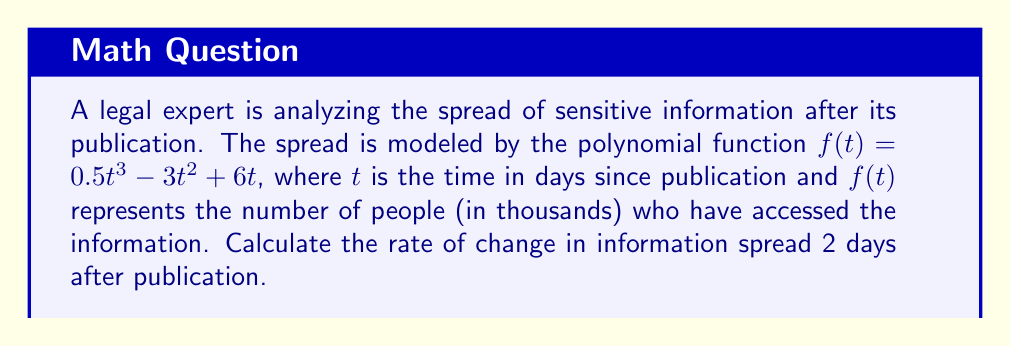Teach me how to tackle this problem. To find the rate of change at a specific point, we need to calculate the derivative of the function and evaluate it at the given point. Here's the step-by-step process:

1) The given function is $f(t) = 0.5t^3 - 3t^2 + 6t$

2) To find the derivative, we apply the power rule to each term:
   $$f'(t) = (0.5t^3)' - (3t^2)' + (6t)'$$
   $$f'(t) = 1.5t^2 - 6t + 6$$

3) This derivative function $f'(t)$ represents the instantaneous rate of change of information spread at any given time $t$.

4) We're asked to find the rate of change 2 days after publication, so we need to evaluate $f'(2)$:
   $$f'(2) = 1.5(2)^2 - 6(2) + 6$$
   $$f'(2) = 1.5(4) - 12 + 6$$
   $$f'(2) = 6 - 12 + 6 = 0$$

5) The unit of the rate of change will be thousands of people per day, as the original function was in thousands of people and the independent variable is in days.
Answer: The rate of change in information spread 2 days after publication is 0 thousand people per day. 